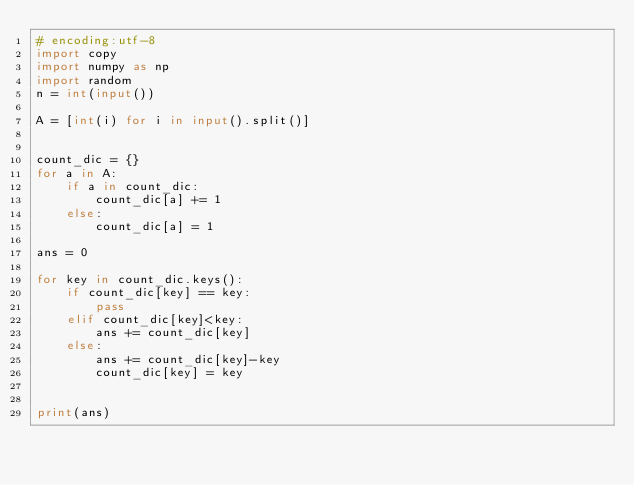Convert code to text. <code><loc_0><loc_0><loc_500><loc_500><_Python_># encoding:utf-8
import copy
import numpy as np
import random
n = int(input())

A = [int(i) for i in input().split()]


count_dic = {}
for a in A:
    if a in count_dic:
        count_dic[a] += 1
    else:
        count_dic[a] = 1

ans = 0

for key in count_dic.keys():
    if count_dic[key] == key:
        pass
    elif count_dic[key]<key:
        ans += count_dic[key]
    else:
        ans += count_dic[key]-key
        count_dic[key] = key


print(ans)
</code> 